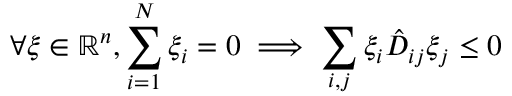Convert formula to latex. <formula><loc_0><loc_0><loc_500><loc_500>\forall \xi \in \mathbb { R } ^ { n } , \sum _ { i = 1 } ^ { N } \xi _ { i } = 0 \implies \sum _ { i , j } \xi _ { i } \hat { D } _ { i j } \xi _ { j } \leq 0</formula> 